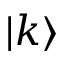Convert formula to latex. <formula><loc_0><loc_0><loc_500><loc_500>| k \rangle</formula> 